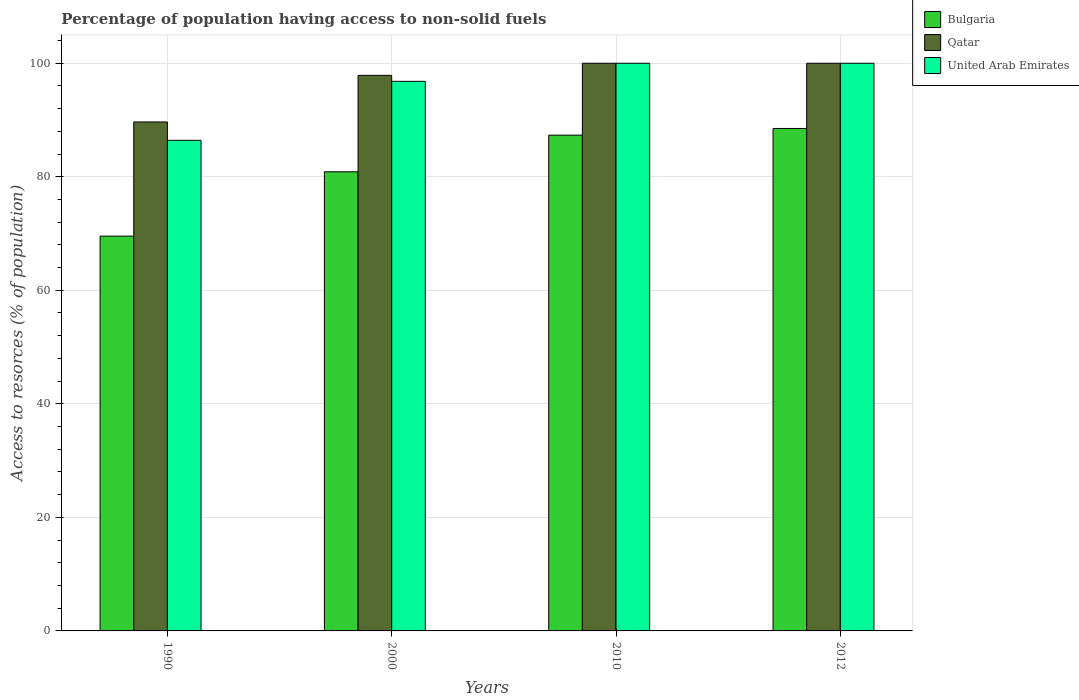How many groups of bars are there?
Your answer should be very brief. 4. Are the number of bars per tick equal to the number of legend labels?
Offer a terse response. Yes. Are the number of bars on each tick of the X-axis equal?
Your answer should be compact. Yes. How many bars are there on the 1st tick from the left?
Your answer should be very brief. 3. How many bars are there on the 1st tick from the right?
Offer a very short reply. 3. What is the percentage of population having access to non-solid fuels in Qatar in 1990?
Your answer should be compact. 89.65. Across all years, what is the maximum percentage of population having access to non-solid fuels in Qatar?
Your answer should be very brief. 99.99. Across all years, what is the minimum percentage of population having access to non-solid fuels in Bulgaria?
Provide a succinct answer. 69.54. In which year was the percentage of population having access to non-solid fuels in United Arab Emirates minimum?
Your response must be concise. 1990. What is the total percentage of population having access to non-solid fuels in Qatar in the graph?
Provide a short and direct response. 387.49. What is the difference between the percentage of population having access to non-solid fuels in Bulgaria in 2010 and the percentage of population having access to non-solid fuels in United Arab Emirates in 1990?
Make the answer very short. 0.91. What is the average percentage of population having access to non-solid fuels in United Arab Emirates per year?
Give a very brief answer. 95.8. In the year 1990, what is the difference between the percentage of population having access to non-solid fuels in Bulgaria and percentage of population having access to non-solid fuels in United Arab Emirates?
Keep it short and to the point. -16.88. In how many years, is the percentage of population having access to non-solid fuels in United Arab Emirates greater than 88 %?
Give a very brief answer. 3. What is the ratio of the percentage of population having access to non-solid fuels in Qatar in 2000 to that in 2012?
Offer a very short reply. 0.98. Is the percentage of population having access to non-solid fuels in Bulgaria in 1990 less than that in 2000?
Keep it short and to the point. Yes. Is the difference between the percentage of population having access to non-solid fuels in Bulgaria in 2000 and 2012 greater than the difference between the percentage of population having access to non-solid fuels in United Arab Emirates in 2000 and 2012?
Provide a succinct answer. No. What is the difference between the highest and the second highest percentage of population having access to non-solid fuels in Bulgaria?
Give a very brief answer. 1.17. What is the difference between the highest and the lowest percentage of population having access to non-solid fuels in United Arab Emirates?
Keep it short and to the point. 13.57. What does the 2nd bar from the left in 2012 represents?
Your answer should be very brief. Qatar. What does the 1st bar from the right in 2010 represents?
Ensure brevity in your answer.  United Arab Emirates. Is it the case that in every year, the sum of the percentage of population having access to non-solid fuels in United Arab Emirates and percentage of population having access to non-solid fuels in Bulgaria is greater than the percentage of population having access to non-solid fuels in Qatar?
Your answer should be compact. Yes. How many bars are there?
Your answer should be compact. 12. What is the difference between two consecutive major ticks on the Y-axis?
Offer a very short reply. 20. Are the values on the major ticks of Y-axis written in scientific E-notation?
Provide a succinct answer. No. Does the graph contain any zero values?
Offer a terse response. No. How many legend labels are there?
Provide a succinct answer. 3. What is the title of the graph?
Your answer should be compact. Percentage of population having access to non-solid fuels. What is the label or title of the X-axis?
Provide a succinct answer. Years. What is the label or title of the Y-axis?
Offer a terse response. Access to resorces (% of population). What is the Access to resorces (% of population) in Bulgaria in 1990?
Offer a very short reply. 69.54. What is the Access to resorces (% of population) in Qatar in 1990?
Ensure brevity in your answer.  89.65. What is the Access to resorces (% of population) of United Arab Emirates in 1990?
Keep it short and to the point. 86.42. What is the Access to resorces (% of population) of Bulgaria in 2000?
Your response must be concise. 80.87. What is the Access to resorces (% of population) in Qatar in 2000?
Provide a short and direct response. 97.86. What is the Access to resorces (% of population) in United Arab Emirates in 2000?
Your answer should be very brief. 96.81. What is the Access to resorces (% of population) of Bulgaria in 2010?
Provide a succinct answer. 87.33. What is the Access to resorces (% of population) in Qatar in 2010?
Ensure brevity in your answer.  99.99. What is the Access to resorces (% of population) in United Arab Emirates in 2010?
Your answer should be compact. 99.99. What is the Access to resorces (% of population) of Bulgaria in 2012?
Offer a very short reply. 88.5. What is the Access to resorces (% of population) of Qatar in 2012?
Give a very brief answer. 99.99. What is the Access to resorces (% of population) of United Arab Emirates in 2012?
Make the answer very short. 99.99. Across all years, what is the maximum Access to resorces (% of population) of Bulgaria?
Offer a terse response. 88.5. Across all years, what is the maximum Access to resorces (% of population) of Qatar?
Your answer should be compact. 99.99. Across all years, what is the maximum Access to resorces (% of population) in United Arab Emirates?
Your answer should be very brief. 99.99. Across all years, what is the minimum Access to resorces (% of population) of Bulgaria?
Provide a succinct answer. 69.54. Across all years, what is the minimum Access to resorces (% of population) in Qatar?
Keep it short and to the point. 89.65. Across all years, what is the minimum Access to resorces (% of population) of United Arab Emirates?
Provide a short and direct response. 86.42. What is the total Access to resorces (% of population) of Bulgaria in the graph?
Provide a succinct answer. 326.24. What is the total Access to resorces (% of population) in Qatar in the graph?
Your answer should be very brief. 387.49. What is the total Access to resorces (% of population) of United Arab Emirates in the graph?
Your response must be concise. 383.2. What is the difference between the Access to resorces (% of population) in Bulgaria in 1990 and that in 2000?
Provide a succinct answer. -11.33. What is the difference between the Access to resorces (% of population) of Qatar in 1990 and that in 2000?
Your answer should be very brief. -8.21. What is the difference between the Access to resorces (% of population) of United Arab Emirates in 1990 and that in 2000?
Your answer should be compact. -10.39. What is the difference between the Access to resorces (% of population) in Bulgaria in 1990 and that in 2010?
Your response must be concise. -17.79. What is the difference between the Access to resorces (% of population) of Qatar in 1990 and that in 2010?
Provide a short and direct response. -10.34. What is the difference between the Access to resorces (% of population) in United Arab Emirates in 1990 and that in 2010?
Offer a terse response. -13.57. What is the difference between the Access to resorces (% of population) in Bulgaria in 1990 and that in 2012?
Provide a succinct answer. -18.96. What is the difference between the Access to resorces (% of population) in Qatar in 1990 and that in 2012?
Your answer should be compact. -10.34. What is the difference between the Access to resorces (% of population) in United Arab Emirates in 1990 and that in 2012?
Your answer should be compact. -13.57. What is the difference between the Access to resorces (% of population) of Bulgaria in 2000 and that in 2010?
Ensure brevity in your answer.  -6.46. What is the difference between the Access to resorces (% of population) of Qatar in 2000 and that in 2010?
Your answer should be compact. -2.13. What is the difference between the Access to resorces (% of population) in United Arab Emirates in 2000 and that in 2010?
Your answer should be very brief. -3.18. What is the difference between the Access to resorces (% of population) of Bulgaria in 2000 and that in 2012?
Provide a short and direct response. -7.63. What is the difference between the Access to resorces (% of population) of Qatar in 2000 and that in 2012?
Provide a short and direct response. -2.13. What is the difference between the Access to resorces (% of population) in United Arab Emirates in 2000 and that in 2012?
Provide a succinct answer. -3.18. What is the difference between the Access to resorces (% of population) in Bulgaria in 2010 and that in 2012?
Ensure brevity in your answer.  -1.17. What is the difference between the Access to resorces (% of population) of United Arab Emirates in 2010 and that in 2012?
Keep it short and to the point. 0. What is the difference between the Access to resorces (% of population) of Bulgaria in 1990 and the Access to resorces (% of population) of Qatar in 2000?
Offer a terse response. -28.32. What is the difference between the Access to resorces (% of population) of Bulgaria in 1990 and the Access to resorces (% of population) of United Arab Emirates in 2000?
Ensure brevity in your answer.  -27.27. What is the difference between the Access to resorces (% of population) in Qatar in 1990 and the Access to resorces (% of population) in United Arab Emirates in 2000?
Offer a very short reply. -7.15. What is the difference between the Access to resorces (% of population) in Bulgaria in 1990 and the Access to resorces (% of population) in Qatar in 2010?
Make the answer very short. -30.45. What is the difference between the Access to resorces (% of population) of Bulgaria in 1990 and the Access to resorces (% of population) of United Arab Emirates in 2010?
Offer a very short reply. -30.45. What is the difference between the Access to resorces (% of population) in Qatar in 1990 and the Access to resorces (% of population) in United Arab Emirates in 2010?
Provide a short and direct response. -10.34. What is the difference between the Access to resorces (% of population) in Bulgaria in 1990 and the Access to resorces (% of population) in Qatar in 2012?
Your response must be concise. -30.45. What is the difference between the Access to resorces (% of population) of Bulgaria in 1990 and the Access to resorces (% of population) of United Arab Emirates in 2012?
Ensure brevity in your answer.  -30.45. What is the difference between the Access to resorces (% of population) of Qatar in 1990 and the Access to resorces (% of population) of United Arab Emirates in 2012?
Your answer should be compact. -10.34. What is the difference between the Access to resorces (% of population) of Bulgaria in 2000 and the Access to resorces (% of population) of Qatar in 2010?
Give a very brief answer. -19.12. What is the difference between the Access to resorces (% of population) of Bulgaria in 2000 and the Access to resorces (% of population) of United Arab Emirates in 2010?
Offer a very short reply. -19.12. What is the difference between the Access to resorces (% of population) of Qatar in 2000 and the Access to resorces (% of population) of United Arab Emirates in 2010?
Your response must be concise. -2.13. What is the difference between the Access to resorces (% of population) of Bulgaria in 2000 and the Access to resorces (% of population) of Qatar in 2012?
Provide a succinct answer. -19.12. What is the difference between the Access to resorces (% of population) of Bulgaria in 2000 and the Access to resorces (% of population) of United Arab Emirates in 2012?
Provide a succinct answer. -19.12. What is the difference between the Access to resorces (% of population) of Qatar in 2000 and the Access to resorces (% of population) of United Arab Emirates in 2012?
Your answer should be compact. -2.13. What is the difference between the Access to resorces (% of population) in Bulgaria in 2010 and the Access to resorces (% of population) in Qatar in 2012?
Keep it short and to the point. -12.66. What is the difference between the Access to resorces (% of population) in Bulgaria in 2010 and the Access to resorces (% of population) in United Arab Emirates in 2012?
Your answer should be compact. -12.66. What is the difference between the Access to resorces (% of population) of Qatar in 2010 and the Access to resorces (% of population) of United Arab Emirates in 2012?
Your response must be concise. 0. What is the average Access to resorces (% of population) of Bulgaria per year?
Offer a terse response. 81.56. What is the average Access to resorces (% of population) in Qatar per year?
Your answer should be compact. 96.87. What is the average Access to resorces (% of population) of United Arab Emirates per year?
Your answer should be very brief. 95.8. In the year 1990, what is the difference between the Access to resorces (% of population) in Bulgaria and Access to resorces (% of population) in Qatar?
Ensure brevity in your answer.  -20.11. In the year 1990, what is the difference between the Access to resorces (% of population) in Bulgaria and Access to resorces (% of population) in United Arab Emirates?
Make the answer very short. -16.88. In the year 1990, what is the difference between the Access to resorces (% of population) of Qatar and Access to resorces (% of population) of United Arab Emirates?
Ensure brevity in your answer.  3.24. In the year 2000, what is the difference between the Access to resorces (% of population) in Bulgaria and Access to resorces (% of population) in Qatar?
Your answer should be very brief. -16.99. In the year 2000, what is the difference between the Access to resorces (% of population) in Bulgaria and Access to resorces (% of population) in United Arab Emirates?
Make the answer very short. -15.93. In the year 2000, what is the difference between the Access to resorces (% of population) of Qatar and Access to resorces (% of population) of United Arab Emirates?
Give a very brief answer. 1.05. In the year 2010, what is the difference between the Access to resorces (% of population) in Bulgaria and Access to resorces (% of population) in Qatar?
Offer a terse response. -12.66. In the year 2010, what is the difference between the Access to resorces (% of population) in Bulgaria and Access to resorces (% of population) in United Arab Emirates?
Offer a terse response. -12.66. In the year 2012, what is the difference between the Access to resorces (% of population) of Bulgaria and Access to resorces (% of population) of Qatar?
Your answer should be compact. -11.49. In the year 2012, what is the difference between the Access to resorces (% of population) of Bulgaria and Access to resorces (% of population) of United Arab Emirates?
Make the answer very short. -11.49. In the year 2012, what is the difference between the Access to resorces (% of population) of Qatar and Access to resorces (% of population) of United Arab Emirates?
Offer a terse response. 0. What is the ratio of the Access to resorces (% of population) of Bulgaria in 1990 to that in 2000?
Offer a terse response. 0.86. What is the ratio of the Access to resorces (% of population) in Qatar in 1990 to that in 2000?
Give a very brief answer. 0.92. What is the ratio of the Access to resorces (% of population) of United Arab Emirates in 1990 to that in 2000?
Ensure brevity in your answer.  0.89. What is the ratio of the Access to resorces (% of population) of Bulgaria in 1990 to that in 2010?
Provide a succinct answer. 0.8. What is the ratio of the Access to resorces (% of population) in Qatar in 1990 to that in 2010?
Offer a terse response. 0.9. What is the ratio of the Access to resorces (% of population) in United Arab Emirates in 1990 to that in 2010?
Provide a short and direct response. 0.86. What is the ratio of the Access to resorces (% of population) of Bulgaria in 1990 to that in 2012?
Your answer should be very brief. 0.79. What is the ratio of the Access to resorces (% of population) of Qatar in 1990 to that in 2012?
Offer a terse response. 0.9. What is the ratio of the Access to resorces (% of population) of United Arab Emirates in 1990 to that in 2012?
Your answer should be very brief. 0.86. What is the ratio of the Access to resorces (% of population) in Bulgaria in 2000 to that in 2010?
Provide a succinct answer. 0.93. What is the ratio of the Access to resorces (% of population) in Qatar in 2000 to that in 2010?
Provide a short and direct response. 0.98. What is the ratio of the Access to resorces (% of population) of United Arab Emirates in 2000 to that in 2010?
Give a very brief answer. 0.97. What is the ratio of the Access to resorces (% of population) of Bulgaria in 2000 to that in 2012?
Keep it short and to the point. 0.91. What is the ratio of the Access to resorces (% of population) in Qatar in 2000 to that in 2012?
Offer a terse response. 0.98. What is the ratio of the Access to resorces (% of population) in United Arab Emirates in 2000 to that in 2012?
Provide a succinct answer. 0.97. What is the ratio of the Access to resorces (% of population) of Bulgaria in 2010 to that in 2012?
Give a very brief answer. 0.99. What is the ratio of the Access to resorces (% of population) in Qatar in 2010 to that in 2012?
Offer a terse response. 1. What is the ratio of the Access to resorces (% of population) in United Arab Emirates in 2010 to that in 2012?
Your answer should be compact. 1. What is the difference between the highest and the second highest Access to resorces (% of population) of Bulgaria?
Your response must be concise. 1.17. What is the difference between the highest and the second highest Access to resorces (% of population) in United Arab Emirates?
Your answer should be very brief. 0. What is the difference between the highest and the lowest Access to resorces (% of population) of Bulgaria?
Provide a succinct answer. 18.96. What is the difference between the highest and the lowest Access to resorces (% of population) in Qatar?
Offer a terse response. 10.34. What is the difference between the highest and the lowest Access to resorces (% of population) of United Arab Emirates?
Your answer should be compact. 13.57. 